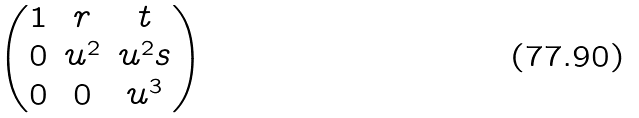Convert formula to latex. <formula><loc_0><loc_0><loc_500><loc_500>\begin{pmatrix} 1 & r & t \\ 0 & u ^ { 2 } & u ^ { 2 } s \\ 0 & 0 & u ^ { 3 } \end{pmatrix}</formula> 